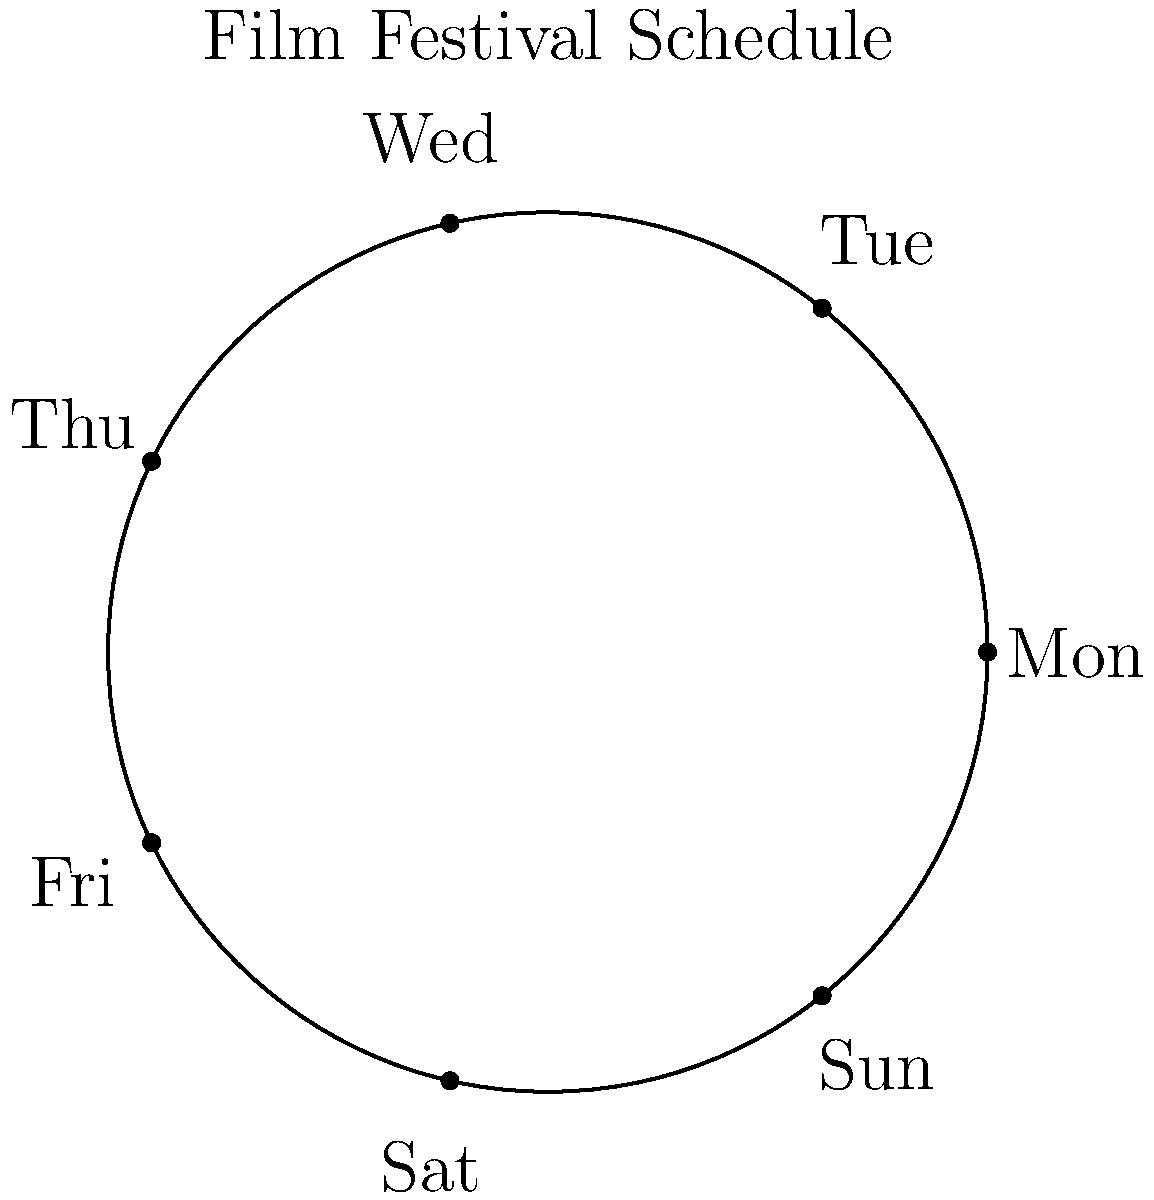A classic film festival is scheduled to rotate through 7 different film genres, one for each day of the week, as shown in the circular diagram. If the festival starts with a noir film on Monday and follows a clockwise rotation, on which day will the festival show a western film for the 100th time? To solve this problem, we need to follow these steps:

1) First, let's assign numbers to each day of the week:
   Monday (1), Tuesday (2), Wednesday (3), Thursday (4), Friday (5), Saturday (6), Sunday (7)

2) The festival rotates through 7 genres, one for each day. This forms a cyclic group of order 7.

3) To find which day the 100th western will be shown, we need to calculate:
   $$(100 - 1) \mod 7 = 99 \mod 7 = 1$$

   We subtract 1 because the first western is shown on day 1 (Monday).

4) The result 1 means that after 99 full cycles, we end up back at the starting point.

5) Therefore, the 100th western will be shown on the same day as the 1st western, which is Monday.

This demonstrates the cyclic nature of the festival schedule, where after every 7 screenings of a particular genre, it returns to the same day of the week.
Answer: Monday 